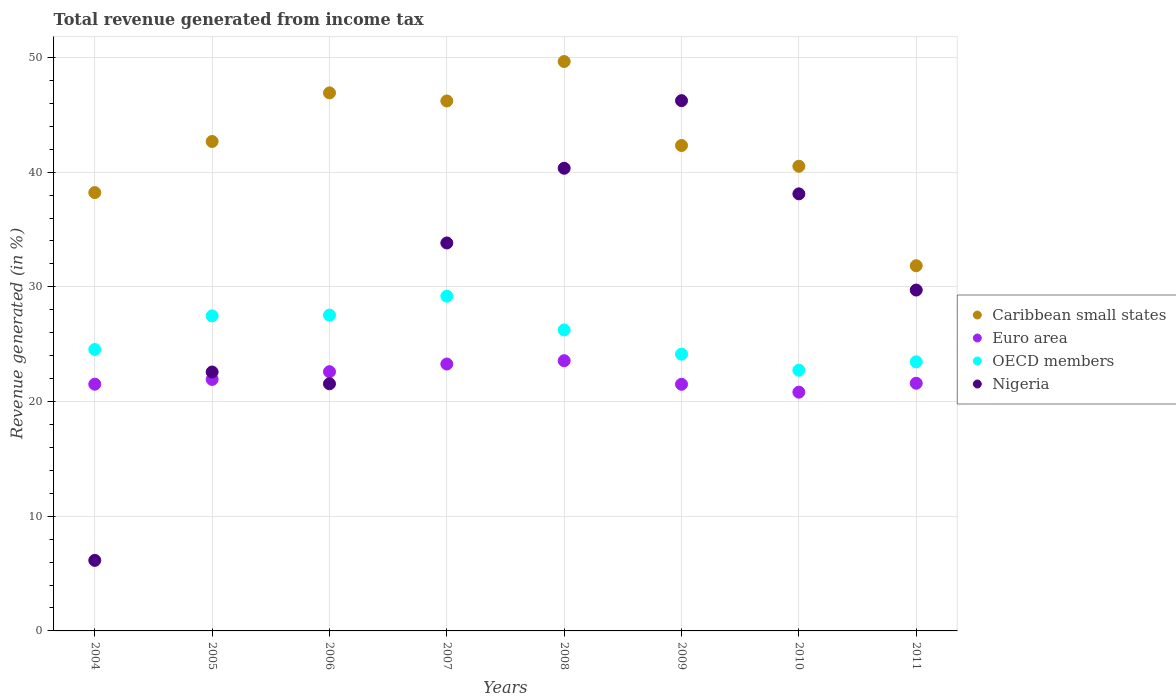How many different coloured dotlines are there?
Provide a short and direct response. 4. Is the number of dotlines equal to the number of legend labels?
Offer a very short reply. Yes. What is the total revenue generated in OECD members in 2004?
Make the answer very short. 24.54. Across all years, what is the maximum total revenue generated in OECD members?
Ensure brevity in your answer.  29.19. Across all years, what is the minimum total revenue generated in OECD members?
Give a very brief answer. 22.73. What is the total total revenue generated in Euro area in the graph?
Your answer should be very brief. 176.78. What is the difference between the total revenue generated in Euro area in 2004 and that in 2009?
Offer a very short reply. 0.01. What is the difference between the total revenue generated in OECD members in 2007 and the total revenue generated in Caribbean small states in 2008?
Keep it short and to the point. -20.46. What is the average total revenue generated in Euro area per year?
Your answer should be compact. 22.1. In the year 2009, what is the difference between the total revenue generated in Caribbean small states and total revenue generated in OECD members?
Your response must be concise. 18.19. What is the ratio of the total revenue generated in OECD members in 2004 to that in 2007?
Ensure brevity in your answer.  0.84. Is the total revenue generated in Nigeria in 2007 less than that in 2011?
Your answer should be very brief. No. What is the difference between the highest and the second highest total revenue generated in Nigeria?
Offer a terse response. 5.9. What is the difference between the highest and the lowest total revenue generated in OECD members?
Provide a short and direct response. 6.46. In how many years, is the total revenue generated in Nigeria greater than the average total revenue generated in Nigeria taken over all years?
Your response must be concise. 4. Is the sum of the total revenue generated in OECD members in 2008 and 2010 greater than the maximum total revenue generated in Euro area across all years?
Your answer should be compact. Yes. Is it the case that in every year, the sum of the total revenue generated in Nigeria and total revenue generated in OECD members  is greater than the sum of total revenue generated in Euro area and total revenue generated in Caribbean small states?
Your response must be concise. No. Is it the case that in every year, the sum of the total revenue generated in OECD members and total revenue generated in Caribbean small states  is greater than the total revenue generated in Nigeria?
Give a very brief answer. Yes. Does the total revenue generated in Caribbean small states monotonically increase over the years?
Offer a terse response. No. Is the total revenue generated in Caribbean small states strictly greater than the total revenue generated in OECD members over the years?
Give a very brief answer. Yes. How many dotlines are there?
Your response must be concise. 4. What is the difference between two consecutive major ticks on the Y-axis?
Your answer should be compact. 10. Are the values on the major ticks of Y-axis written in scientific E-notation?
Provide a short and direct response. No. Does the graph contain any zero values?
Offer a very short reply. No. What is the title of the graph?
Offer a very short reply. Total revenue generated from income tax. Does "Bangladesh" appear as one of the legend labels in the graph?
Your answer should be compact. No. What is the label or title of the X-axis?
Provide a short and direct response. Years. What is the label or title of the Y-axis?
Your response must be concise. Revenue generated (in %). What is the Revenue generated (in %) of Caribbean small states in 2004?
Offer a terse response. 38.22. What is the Revenue generated (in %) of Euro area in 2004?
Offer a very short reply. 21.51. What is the Revenue generated (in %) in OECD members in 2004?
Make the answer very short. 24.54. What is the Revenue generated (in %) of Nigeria in 2004?
Your answer should be very brief. 6.15. What is the Revenue generated (in %) in Caribbean small states in 2005?
Offer a very short reply. 42.67. What is the Revenue generated (in %) of Euro area in 2005?
Your response must be concise. 21.93. What is the Revenue generated (in %) in OECD members in 2005?
Provide a short and direct response. 27.47. What is the Revenue generated (in %) in Nigeria in 2005?
Offer a terse response. 22.57. What is the Revenue generated (in %) of Caribbean small states in 2006?
Offer a terse response. 46.91. What is the Revenue generated (in %) in Euro area in 2006?
Offer a very short reply. 22.6. What is the Revenue generated (in %) in OECD members in 2006?
Make the answer very short. 27.53. What is the Revenue generated (in %) in Nigeria in 2006?
Your answer should be compact. 21.55. What is the Revenue generated (in %) of Caribbean small states in 2007?
Keep it short and to the point. 46.21. What is the Revenue generated (in %) in Euro area in 2007?
Offer a very short reply. 23.27. What is the Revenue generated (in %) of OECD members in 2007?
Offer a very short reply. 29.19. What is the Revenue generated (in %) in Nigeria in 2007?
Make the answer very short. 33.83. What is the Revenue generated (in %) of Caribbean small states in 2008?
Provide a succinct answer. 49.65. What is the Revenue generated (in %) of Euro area in 2008?
Your response must be concise. 23.56. What is the Revenue generated (in %) in OECD members in 2008?
Keep it short and to the point. 26.24. What is the Revenue generated (in %) of Nigeria in 2008?
Keep it short and to the point. 40.34. What is the Revenue generated (in %) in Caribbean small states in 2009?
Offer a terse response. 42.32. What is the Revenue generated (in %) of Euro area in 2009?
Give a very brief answer. 21.5. What is the Revenue generated (in %) in OECD members in 2009?
Your answer should be very brief. 24.13. What is the Revenue generated (in %) in Nigeria in 2009?
Offer a very short reply. 46.23. What is the Revenue generated (in %) in Caribbean small states in 2010?
Offer a terse response. 40.51. What is the Revenue generated (in %) of Euro area in 2010?
Your answer should be compact. 20.82. What is the Revenue generated (in %) in OECD members in 2010?
Provide a short and direct response. 22.73. What is the Revenue generated (in %) in Nigeria in 2010?
Offer a terse response. 38.11. What is the Revenue generated (in %) of Caribbean small states in 2011?
Your answer should be compact. 31.84. What is the Revenue generated (in %) of Euro area in 2011?
Provide a succinct answer. 21.59. What is the Revenue generated (in %) in OECD members in 2011?
Keep it short and to the point. 23.46. What is the Revenue generated (in %) in Nigeria in 2011?
Your answer should be very brief. 29.72. Across all years, what is the maximum Revenue generated (in %) of Caribbean small states?
Your answer should be very brief. 49.65. Across all years, what is the maximum Revenue generated (in %) in Euro area?
Offer a very short reply. 23.56. Across all years, what is the maximum Revenue generated (in %) in OECD members?
Provide a short and direct response. 29.19. Across all years, what is the maximum Revenue generated (in %) in Nigeria?
Ensure brevity in your answer.  46.23. Across all years, what is the minimum Revenue generated (in %) of Caribbean small states?
Provide a short and direct response. 31.84. Across all years, what is the minimum Revenue generated (in %) of Euro area?
Keep it short and to the point. 20.82. Across all years, what is the minimum Revenue generated (in %) in OECD members?
Provide a short and direct response. 22.73. Across all years, what is the minimum Revenue generated (in %) of Nigeria?
Your response must be concise. 6.15. What is the total Revenue generated (in %) of Caribbean small states in the graph?
Offer a terse response. 338.33. What is the total Revenue generated (in %) of Euro area in the graph?
Provide a succinct answer. 176.78. What is the total Revenue generated (in %) in OECD members in the graph?
Provide a short and direct response. 205.29. What is the total Revenue generated (in %) of Nigeria in the graph?
Ensure brevity in your answer.  238.5. What is the difference between the Revenue generated (in %) in Caribbean small states in 2004 and that in 2005?
Give a very brief answer. -4.45. What is the difference between the Revenue generated (in %) of Euro area in 2004 and that in 2005?
Your response must be concise. -0.42. What is the difference between the Revenue generated (in %) in OECD members in 2004 and that in 2005?
Ensure brevity in your answer.  -2.93. What is the difference between the Revenue generated (in %) in Nigeria in 2004 and that in 2005?
Keep it short and to the point. -16.42. What is the difference between the Revenue generated (in %) in Caribbean small states in 2004 and that in 2006?
Ensure brevity in your answer.  -8.69. What is the difference between the Revenue generated (in %) of Euro area in 2004 and that in 2006?
Make the answer very short. -1.09. What is the difference between the Revenue generated (in %) of OECD members in 2004 and that in 2006?
Offer a very short reply. -3. What is the difference between the Revenue generated (in %) of Nigeria in 2004 and that in 2006?
Offer a very short reply. -15.4. What is the difference between the Revenue generated (in %) in Caribbean small states in 2004 and that in 2007?
Provide a succinct answer. -7.99. What is the difference between the Revenue generated (in %) in Euro area in 2004 and that in 2007?
Keep it short and to the point. -1.76. What is the difference between the Revenue generated (in %) of OECD members in 2004 and that in 2007?
Give a very brief answer. -4.65. What is the difference between the Revenue generated (in %) of Nigeria in 2004 and that in 2007?
Your answer should be very brief. -27.68. What is the difference between the Revenue generated (in %) of Caribbean small states in 2004 and that in 2008?
Give a very brief answer. -11.43. What is the difference between the Revenue generated (in %) of Euro area in 2004 and that in 2008?
Offer a very short reply. -2.05. What is the difference between the Revenue generated (in %) in OECD members in 2004 and that in 2008?
Provide a succinct answer. -1.7. What is the difference between the Revenue generated (in %) of Nigeria in 2004 and that in 2008?
Give a very brief answer. -34.19. What is the difference between the Revenue generated (in %) of Caribbean small states in 2004 and that in 2009?
Make the answer very short. -4.11. What is the difference between the Revenue generated (in %) in Euro area in 2004 and that in 2009?
Offer a terse response. 0.01. What is the difference between the Revenue generated (in %) in OECD members in 2004 and that in 2009?
Provide a succinct answer. 0.41. What is the difference between the Revenue generated (in %) in Nigeria in 2004 and that in 2009?
Offer a very short reply. -40.08. What is the difference between the Revenue generated (in %) of Caribbean small states in 2004 and that in 2010?
Provide a short and direct response. -2.3. What is the difference between the Revenue generated (in %) in Euro area in 2004 and that in 2010?
Offer a very short reply. 0.69. What is the difference between the Revenue generated (in %) of OECD members in 2004 and that in 2010?
Make the answer very short. 1.81. What is the difference between the Revenue generated (in %) in Nigeria in 2004 and that in 2010?
Your response must be concise. -31.96. What is the difference between the Revenue generated (in %) of Caribbean small states in 2004 and that in 2011?
Provide a short and direct response. 6.38. What is the difference between the Revenue generated (in %) of Euro area in 2004 and that in 2011?
Make the answer very short. -0.08. What is the difference between the Revenue generated (in %) in OECD members in 2004 and that in 2011?
Ensure brevity in your answer.  1.07. What is the difference between the Revenue generated (in %) in Nigeria in 2004 and that in 2011?
Keep it short and to the point. -23.57. What is the difference between the Revenue generated (in %) of Caribbean small states in 2005 and that in 2006?
Ensure brevity in your answer.  -4.24. What is the difference between the Revenue generated (in %) in Euro area in 2005 and that in 2006?
Your answer should be very brief. -0.67. What is the difference between the Revenue generated (in %) of OECD members in 2005 and that in 2006?
Offer a terse response. -0.07. What is the difference between the Revenue generated (in %) of Nigeria in 2005 and that in 2006?
Give a very brief answer. 1.03. What is the difference between the Revenue generated (in %) in Caribbean small states in 2005 and that in 2007?
Offer a terse response. -3.53. What is the difference between the Revenue generated (in %) in Euro area in 2005 and that in 2007?
Your response must be concise. -1.34. What is the difference between the Revenue generated (in %) of OECD members in 2005 and that in 2007?
Provide a short and direct response. -1.72. What is the difference between the Revenue generated (in %) of Nigeria in 2005 and that in 2007?
Your answer should be compact. -11.25. What is the difference between the Revenue generated (in %) of Caribbean small states in 2005 and that in 2008?
Your answer should be compact. -6.97. What is the difference between the Revenue generated (in %) in Euro area in 2005 and that in 2008?
Your response must be concise. -1.63. What is the difference between the Revenue generated (in %) in OECD members in 2005 and that in 2008?
Offer a very short reply. 1.23. What is the difference between the Revenue generated (in %) in Nigeria in 2005 and that in 2008?
Ensure brevity in your answer.  -17.77. What is the difference between the Revenue generated (in %) in Caribbean small states in 2005 and that in 2009?
Your answer should be compact. 0.35. What is the difference between the Revenue generated (in %) of Euro area in 2005 and that in 2009?
Ensure brevity in your answer.  0.42. What is the difference between the Revenue generated (in %) in OECD members in 2005 and that in 2009?
Your answer should be compact. 3.34. What is the difference between the Revenue generated (in %) of Nigeria in 2005 and that in 2009?
Keep it short and to the point. -23.66. What is the difference between the Revenue generated (in %) of Caribbean small states in 2005 and that in 2010?
Your answer should be compact. 2.16. What is the difference between the Revenue generated (in %) of Euro area in 2005 and that in 2010?
Your response must be concise. 1.11. What is the difference between the Revenue generated (in %) of OECD members in 2005 and that in 2010?
Your answer should be very brief. 4.74. What is the difference between the Revenue generated (in %) of Nigeria in 2005 and that in 2010?
Your response must be concise. -15.53. What is the difference between the Revenue generated (in %) in Caribbean small states in 2005 and that in 2011?
Keep it short and to the point. 10.83. What is the difference between the Revenue generated (in %) of Euro area in 2005 and that in 2011?
Make the answer very short. 0.33. What is the difference between the Revenue generated (in %) of OECD members in 2005 and that in 2011?
Ensure brevity in your answer.  4.01. What is the difference between the Revenue generated (in %) in Nigeria in 2005 and that in 2011?
Offer a terse response. -7.15. What is the difference between the Revenue generated (in %) in Caribbean small states in 2006 and that in 2007?
Provide a succinct answer. 0.7. What is the difference between the Revenue generated (in %) in Euro area in 2006 and that in 2007?
Offer a very short reply. -0.67. What is the difference between the Revenue generated (in %) of OECD members in 2006 and that in 2007?
Keep it short and to the point. -1.65. What is the difference between the Revenue generated (in %) in Nigeria in 2006 and that in 2007?
Ensure brevity in your answer.  -12.28. What is the difference between the Revenue generated (in %) in Caribbean small states in 2006 and that in 2008?
Keep it short and to the point. -2.74. What is the difference between the Revenue generated (in %) in Euro area in 2006 and that in 2008?
Make the answer very short. -0.96. What is the difference between the Revenue generated (in %) in OECD members in 2006 and that in 2008?
Provide a succinct answer. 1.29. What is the difference between the Revenue generated (in %) in Nigeria in 2006 and that in 2008?
Ensure brevity in your answer.  -18.79. What is the difference between the Revenue generated (in %) in Caribbean small states in 2006 and that in 2009?
Make the answer very short. 4.59. What is the difference between the Revenue generated (in %) in Euro area in 2006 and that in 2009?
Your answer should be very brief. 1.1. What is the difference between the Revenue generated (in %) of OECD members in 2006 and that in 2009?
Give a very brief answer. 3.4. What is the difference between the Revenue generated (in %) in Nigeria in 2006 and that in 2009?
Your answer should be very brief. -24.69. What is the difference between the Revenue generated (in %) in Caribbean small states in 2006 and that in 2010?
Your answer should be very brief. 6.4. What is the difference between the Revenue generated (in %) of Euro area in 2006 and that in 2010?
Your answer should be very brief. 1.78. What is the difference between the Revenue generated (in %) of OECD members in 2006 and that in 2010?
Provide a succinct answer. 4.8. What is the difference between the Revenue generated (in %) in Nigeria in 2006 and that in 2010?
Offer a very short reply. -16.56. What is the difference between the Revenue generated (in %) in Caribbean small states in 2006 and that in 2011?
Your response must be concise. 15.07. What is the difference between the Revenue generated (in %) of OECD members in 2006 and that in 2011?
Your response must be concise. 4.07. What is the difference between the Revenue generated (in %) in Nigeria in 2006 and that in 2011?
Keep it short and to the point. -8.17. What is the difference between the Revenue generated (in %) of Caribbean small states in 2007 and that in 2008?
Offer a terse response. -3.44. What is the difference between the Revenue generated (in %) of Euro area in 2007 and that in 2008?
Provide a succinct answer. -0.29. What is the difference between the Revenue generated (in %) in OECD members in 2007 and that in 2008?
Your response must be concise. 2.94. What is the difference between the Revenue generated (in %) of Nigeria in 2007 and that in 2008?
Your response must be concise. -6.51. What is the difference between the Revenue generated (in %) in Caribbean small states in 2007 and that in 2009?
Provide a succinct answer. 3.88. What is the difference between the Revenue generated (in %) in Euro area in 2007 and that in 2009?
Keep it short and to the point. 1.77. What is the difference between the Revenue generated (in %) in OECD members in 2007 and that in 2009?
Your answer should be very brief. 5.06. What is the difference between the Revenue generated (in %) of Nigeria in 2007 and that in 2009?
Ensure brevity in your answer.  -12.41. What is the difference between the Revenue generated (in %) in Caribbean small states in 2007 and that in 2010?
Make the answer very short. 5.69. What is the difference between the Revenue generated (in %) of Euro area in 2007 and that in 2010?
Provide a short and direct response. 2.45. What is the difference between the Revenue generated (in %) of OECD members in 2007 and that in 2010?
Give a very brief answer. 6.46. What is the difference between the Revenue generated (in %) in Nigeria in 2007 and that in 2010?
Keep it short and to the point. -4.28. What is the difference between the Revenue generated (in %) in Caribbean small states in 2007 and that in 2011?
Provide a succinct answer. 14.37. What is the difference between the Revenue generated (in %) in Euro area in 2007 and that in 2011?
Provide a succinct answer. 1.68. What is the difference between the Revenue generated (in %) of OECD members in 2007 and that in 2011?
Ensure brevity in your answer.  5.72. What is the difference between the Revenue generated (in %) in Nigeria in 2007 and that in 2011?
Ensure brevity in your answer.  4.11. What is the difference between the Revenue generated (in %) of Caribbean small states in 2008 and that in 2009?
Your answer should be very brief. 7.32. What is the difference between the Revenue generated (in %) of Euro area in 2008 and that in 2009?
Make the answer very short. 2.06. What is the difference between the Revenue generated (in %) in OECD members in 2008 and that in 2009?
Your response must be concise. 2.11. What is the difference between the Revenue generated (in %) in Nigeria in 2008 and that in 2009?
Give a very brief answer. -5.9. What is the difference between the Revenue generated (in %) of Caribbean small states in 2008 and that in 2010?
Keep it short and to the point. 9.13. What is the difference between the Revenue generated (in %) of Euro area in 2008 and that in 2010?
Provide a succinct answer. 2.74. What is the difference between the Revenue generated (in %) in OECD members in 2008 and that in 2010?
Offer a very short reply. 3.51. What is the difference between the Revenue generated (in %) in Nigeria in 2008 and that in 2010?
Give a very brief answer. 2.23. What is the difference between the Revenue generated (in %) in Caribbean small states in 2008 and that in 2011?
Provide a short and direct response. 17.81. What is the difference between the Revenue generated (in %) in Euro area in 2008 and that in 2011?
Offer a very short reply. 1.97. What is the difference between the Revenue generated (in %) of OECD members in 2008 and that in 2011?
Give a very brief answer. 2.78. What is the difference between the Revenue generated (in %) of Nigeria in 2008 and that in 2011?
Ensure brevity in your answer.  10.62. What is the difference between the Revenue generated (in %) in Caribbean small states in 2009 and that in 2010?
Your response must be concise. 1.81. What is the difference between the Revenue generated (in %) in Euro area in 2009 and that in 2010?
Your response must be concise. 0.69. What is the difference between the Revenue generated (in %) in OECD members in 2009 and that in 2010?
Ensure brevity in your answer.  1.4. What is the difference between the Revenue generated (in %) in Nigeria in 2009 and that in 2010?
Ensure brevity in your answer.  8.13. What is the difference between the Revenue generated (in %) in Caribbean small states in 2009 and that in 2011?
Your response must be concise. 10.48. What is the difference between the Revenue generated (in %) in Euro area in 2009 and that in 2011?
Ensure brevity in your answer.  -0.09. What is the difference between the Revenue generated (in %) in OECD members in 2009 and that in 2011?
Your answer should be very brief. 0.67. What is the difference between the Revenue generated (in %) of Nigeria in 2009 and that in 2011?
Your response must be concise. 16.51. What is the difference between the Revenue generated (in %) of Caribbean small states in 2010 and that in 2011?
Offer a very short reply. 8.67. What is the difference between the Revenue generated (in %) of Euro area in 2010 and that in 2011?
Provide a short and direct response. -0.78. What is the difference between the Revenue generated (in %) in OECD members in 2010 and that in 2011?
Give a very brief answer. -0.73. What is the difference between the Revenue generated (in %) of Nigeria in 2010 and that in 2011?
Keep it short and to the point. 8.39. What is the difference between the Revenue generated (in %) of Caribbean small states in 2004 and the Revenue generated (in %) of Euro area in 2005?
Give a very brief answer. 16.29. What is the difference between the Revenue generated (in %) in Caribbean small states in 2004 and the Revenue generated (in %) in OECD members in 2005?
Give a very brief answer. 10.75. What is the difference between the Revenue generated (in %) of Caribbean small states in 2004 and the Revenue generated (in %) of Nigeria in 2005?
Make the answer very short. 15.64. What is the difference between the Revenue generated (in %) in Euro area in 2004 and the Revenue generated (in %) in OECD members in 2005?
Make the answer very short. -5.96. What is the difference between the Revenue generated (in %) in Euro area in 2004 and the Revenue generated (in %) in Nigeria in 2005?
Keep it short and to the point. -1.06. What is the difference between the Revenue generated (in %) of OECD members in 2004 and the Revenue generated (in %) of Nigeria in 2005?
Give a very brief answer. 1.96. What is the difference between the Revenue generated (in %) in Caribbean small states in 2004 and the Revenue generated (in %) in Euro area in 2006?
Your response must be concise. 15.62. What is the difference between the Revenue generated (in %) of Caribbean small states in 2004 and the Revenue generated (in %) of OECD members in 2006?
Your answer should be compact. 10.68. What is the difference between the Revenue generated (in %) of Caribbean small states in 2004 and the Revenue generated (in %) of Nigeria in 2006?
Make the answer very short. 16.67. What is the difference between the Revenue generated (in %) in Euro area in 2004 and the Revenue generated (in %) in OECD members in 2006?
Provide a succinct answer. -6.02. What is the difference between the Revenue generated (in %) in Euro area in 2004 and the Revenue generated (in %) in Nigeria in 2006?
Keep it short and to the point. -0.04. What is the difference between the Revenue generated (in %) in OECD members in 2004 and the Revenue generated (in %) in Nigeria in 2006?
Make the answer very short. 2.99. What is the difference between the Revenue generated (in %) in Caribbean small states in 2004 and the Revenue generated (in %) in Euro area in 2007?
Make the answer very short. 14.95. What is the difference between the Revenue generated (in %) in Caribbean small states in 2004 and the Revenue generated (in %) in OECD members in 2007?
Offer a very short reply. 9.03. What is the difference between the Revenue generated (in %) in Caribbean small states in 2004 and the Revenue generated (in %) in Nigeria in 2007?
Give a very brief answer. 4.39. What is the difference between the Revenue generated (in %) of Euro area in 2004 and the Revenue generated (in %) of OECD members in 2007?
Keep it short and to the point. -7.67. What is the difference between the Revenue generated (in %) in Euro area in 2004 and the Revenue generated (in %) in Nigeria in 2007?
Give a very brief answer. -12.31. What is the difference between the Revenue generated (in %) in OECD members in 2004 and the Revenue generated (in %) in Nigeria in 2007?
Offer a very short reply. -9.29. What is the difference between the Revenue generated (in %) of Caribbean small states in 2004 and the Revenue generated (in %) of Euro area in 2008?
Provide a succinct answer. 14.66. What is the difference between the Revenue generated (in %) of Caribbean small states in 2004 and the Revenue generated (in %) of OECD members in 2008?
Make the answer very short. 11.98. What is the difference between the Revenue generated (in %) in Caribbean small states in 2004 and the Revenue generated (in %) in Nigeria in 2008?
Give a very brief answer. -2.12. What is the difference between the Revenue generated (in %) in Euro area in 2004 and the Revenue generated (in %) in OECD members in 2008?
Your answer should be compact. -4.73. What is the difference between the Revenue generated (in %) in Euro area in 2004 and the Revenue generated (in %) in Nigeria in 2008?
Provide a succinct answer. -18.83. What is the difference between the Revenue generated (in %) of OECD members in 2004 and the Revenue generated (in %) of Nigeria in 2008?
Make the answer very short. -15.8. What is the difference between the Revenue generated (in %) in Caribbean small states in 2004 and the Revenue generated (in %) in Euro area in 2009?
Your answer should be very brief. 16.71. What is the difference between the Revenue generated (in %) of Caribbean small states in 2004 and the Revenue generated (in %) of OECD members in 2009?
Your answer should be very brief. 14.09. What is the difference between the Revenue generated (in %) in Caribbean small states in 2004 and the Revenue generated (in %) in Nigeria in 2009?
Give a very brief answer. -8.02. What is the difference between the Revenue generated (in %) in Euro area in 2004 and the Revenue generated (in %) in OECD members in 2009?
Make the answer very short. -2.62. What is the difference between the Revenue generated (in %) in Euro area in 2004 and the Revenue generated (in %) in Nigeria in 2009?
Make the answer very short. -24.72. What is the difference between the Revenue generated (in %) of OECD members in 2004 and the Revenue generated (in %) of Nigeria in 2009?
Offer a terse response. -21.7. What is the difference between the Revenue generated (in %) of Caribbean small states in 2004 and the Revenue generated (in %) of Euro area in 2010?
Offer a terse response. 17.4. What is the difference between the Revenue generated (in %) of Caribbean small states in 2004 and the Revenue generated (in %) of OECD members in 2010?
Keep it short and to the point. 15.49. What is the difference between the Revenue generated (in %) of Caribbean small states in 2004 and the Revenue generated (in %) of Nigeria in 2010?
Your answer should be very brief. 0.11. What is the difference between the Revenue generated (in %) in Euro area in 2004 and the Revenue generated (in %) in OECD members in 2010?
Give a very brief answer. -1.22. What is the difference between the Revenue generated (in %) in Euro area in 2004 and the Revenue generated (in %) in Nigeria in 2010?
Provide a succinct answer. -16.6. What is the difference between the Revenue generated (in %) in OECD members in 2004 and the Revenue generated (in %) in Nigeria in 2010?
Your response must be concise. -13.57. What is the difference between the Revenue generated (in %) of Caribbean small states in 2004 and the Revenue generated (in %) of Euro area in 2011?
Offer a very short reply. 16.62. What is the difference between the Revenue generated (in %) in Caribbean small states in 2004 and the Revenue generated (in %) in OECD members in 2011?
Your response must be concise. 14.75. What is the difference between the Revenue generated (in %) in Caribbean small states in 2004 and the Revenue generated (in %) in Nigeria in 2011?
Give a very brief answer. 8.5. What is the difference between the Revenue generated (in %) in Euro area in 2004 and the Revenue generated (in %) in OECD members in 2011?
Give a very brief answer. -1.95. What is the difference between the Revenue generated (in %) of Euro area in 2004 and the Revenue generated (in %) of Nigeria in 2011?
Your answer should be compact. -8.21. What is the difference between the Revenue generated (in %) of OECD members in 2004 and the Revenue generated (in %) of Nigeria in 2011?
Your answer should be very brief. -5.18. What is the difference between the Revenue generated (in %) in Caribbean small states in 2005 and the Revenue generated (in %) in Euro area in 2006?
Your answer should be very brief. 20.07. What is the difference between the Revenue generated (in %) in Caribbean small states in 2005 and the Revenue generated (in %) in OECD members in 2006?
Provide a succinct answer. 15.14. What is the difference between the Revenue generated (in %) of Caribbean small states in 2005 and the Revenue generated (in %) of Nigeria in 2006?
Provide a short and direct response. 21.12. What is the difference between the Revenue generated (in %) of Euro area in 2005 and the Revenue generated (in %) of OECD members in 2006?
Your answer should be compact. -5.61. What is the difference between the Revenue generated (in %) of Euro area in 2005 and the Revenue generated (in %) of Nigeria in 2006?
Provide a succinct answer. 0.38. What is the difference between the Revenue generated (in %) in OECD members in 2005 and the Revenue generated (in %) in Nigeria in 2006?
Your response must be concise. 5.92. What is the difference between the Revenue generated (in %) in Caribbean small states in 2005 and the Revenue generated (in %) in Euro area in 2007?
Keep it short and to the point. 19.4. What is the difference between the Revenue generated (in %) in Caribbean small states in 2005 and the Revenue generated (in %) in OECD members in 2007?
Your answer should be very brief. 13.49. What is the difference between the Revenue generated (in %) of Caribbean small states in 2005 and the Revenue generated (in %) of Nigeria in 2007?
Offer a terse response. 8.85. What is the difference between the Revenue generated (in %) in Euro area in 2005 and the Revenue generated (in %) in OECD members in 2007?
Keep it short and to the point. -7.26. What is the difference between the Revenue generated (in %) in Euro area in 2005 and the Revenue generated (in %) in Nigeria in 2007?
Give a very brief answer. -11.9. What is the difference between the Revenue generated (in %) in OECD members in 2005 and the Revenue generated (in %) in Nigeria in 2007?
Give a very brief answer. -6.36. What is the difference between the Revenue generated (in %) in Caribbean small states in 2005 and the Revenue generated (in %) in Euro area in 2008?
Provide a succinct answer. 19.11. What is the difference between the Revenue generated (in %) in Caribbean small states in 2005 and the Revenue generated (in %) in OECD members in 2008?
Your answer should be very brief. 16.43. What is the difference between the Revenue generated (in %) in Caribbean small states in 2005 and the Revenue generated (in %) in Nigeria in 2008?
Your answer should be very brief. 2.33. What is the difference between the Revenue generated (in %) in Euro area in 2005 and the Revenue generated (in %) in OECD members in 2008?
Make the answer very short. -4.31. What is the difference between the Revenue generated (in %) of Euro area in 2005 and the Revenue generated (in %) of Nigeria in 2008?
Give a very brief answer. -18.41. What is the difference between the Revenue generated (in %) of OECD members in 2005 and the Revenue generated (in %) of Nigeria in 2008?
Offer a very short reply. -12.87. What is the difference between the Revenue generated (in %) in Caribbean small states in 2005 and the Revenue generated (in %) in Euro area in 2009?
Keep it short and to the point. 21.17. What is the difference between the Revenue generated (in %) of Caribbean small states in 2005 and the Revenue generated (in %) of OECD members in 2009?
Your answer should be compact. 18.54. What is the difference between the Revenue generated (in %) of Caribbean small states in 2005 and the Revenue generated (in %) of Nigeria in 2009?
Your answer should be very brief. -3.56. What is the difference between the Revenue generated (in %) in Euro area in 2005 and the Revenue generated (in %) in OECD members in 2009?
Your answer should be very brief. -2.2. What is the difference between the Revenue generated (in %) in Euro area in 2005 and the Revenue generated (in %) in Nigeria in 2009?
Ensure brevity in your answer.  -24.3. What is the difference between the Revenue generated (in %) in OECD members in 2005 and the Revenue generated (in %) in Nigeria in 2009?
Keep it short and to the point. -18.76. What is the difference between the Revenue generated (in %) of Caribbean small states in 2005 and the Revenue generated (in %) of Euro area in 2010?
Keep it short and to the point. 21.85. What is the difference between the Revenue generated (in %) in Caribbean small states in 2005 and the Revenue generated (in %) in OECD members in 2010?
Provide a succinct answer. 19.94. What is the difference between the Revenue generated (in %) of Caribbean small states in 2005 and the Revenue generated (in %) of Nigeria in 2010?
Your response must be concise. 4.56. What is the difference between the Revenue generated (in %) in Euro area in 2005 and the Revenue generated (in %) in OECD members in 2010?
Ensure brevity in your answer.  -0.8. What is the difference between the Revenue generated (in %) in Euro area in 2005 and the Revenue generated (in %) in Nigeria in 2010?
Offer a very short reply. -16.18. What is the difference between the Revenue generated (in %) of OECD members in 2005 and the Revenue generated (in %) of Nigeria in 2010?
Provide a short and direct response. -10.64. What is the difference between the Revenue generated (in %) of Caribbean small states in 2005 and the Revenue generated (in %) of Euro area in 2011?
Ensure brevity in your answer.  21.08. What is the difference between the Revenue generated (in %) in Caribbean small states in 2005 and the Revenue generated (in %) in OECD members in 2011?
Your answer should be compact. 19.21. What is the difference between the Revenue generated (in %) of Caribbean small states in 2005 and the Revenue generated (in %) of Nigeria in 2011?
Your response must be concise. 12.95. What is the difference between the Revenue generated (in %) in Euro area in 2005 and the Revenue generated (in %) in OECD members in 2011?
Keep it short and to the point. -1.53. What is the difference between the Revenue generated (in %) of Euro area in 2005 and the Revenue generated (in %) of Nigeria in 2011?
Ensure brevity in your answer.  -7.79. What is the difference between the Revenue generated (in %) in OECD members in 2005 and the Revenue generated (in %) in Nigeria in 2011?
Your answer should be very brief. -2.25. What is the difference between the Revenue generated (in %) in Caribbean small states in 2006 and the Revenue generated (in %) in Euro area in 2007?
Your answer should be compact. 23.64. What is the difference between the Revenue generated (in %) of Caribbean small states in 2006 and the Revenue generated (in %) of OECD members in 2007?
Your response must be concise. 17.72. What is the difference between the Revenue generated (in %) of Caribbean small states in 2006 and the Revenue generated (in %) of Nigeria in 2007?
Offer a very short reply. 13.08. What is the difference between the Revenue generated (in %) of Euro area in 2006 and the Revenue generated (in %) of OECD members in 2007?
Keep it short and to the point. -6.59. What is the difference between the Revenue generated (in %) of Euro area in 2006 and the Revenue generated (in %) of Nigeria in 2007?
Keep it short and to the point. -11.23. What is the difference between the Revenue generated (in %) in OECD members in 2006 and the Revenue generated (in %) in Nigeria in 2007?
Offer a very short reply. -6.29. What is the difference between the Revenue generated (in %) in Caribbean small states in 2006 and the Revenue generated (in %) in Euro area in 2008?
Provide a succinct answer. 23.35. What is the difference between the Revenue generated (in %) in Caribbean small states in 2006 and the Revenue generated (in %) in OECD members in 2008?
Your response must be concise. 20.67. What is the difference between the Revenue generated (in %) of Caribbean small states in 2006 and the Revenue generated (in %) of Nigeria in 2008?
Your response must be concise. 6.57. What is the difference between the Revenue generated (in %) of Euro area in 2006 and the Revenue generated (in %) of OECD members in 2008?
Your response must be concise. -3.64. What is the difference between the Revenue generated (in %) in Euro area in 2006 and the Revenue generated (in %) in Nigeria in 2008?
Your response must be concise. -17.74. What is the difference between the Revenue generated (in %) of OECD members in 2006 and the Revenue generated (in %) of Nigeria in 2008?
Your answer should be very brief. -12.8. What is the difference between the Revenue generated (in %) of Caribbean small states in 2006 and the Revenue generated (in %) of Euro area in 2009?
Offer a terse response. 25.41. What is the difference between the Revenue generated (in %) in Caribbean small states in 2006 and the Revenue generated (in %) in OECD members in 2009?
Your answer should be very brief. 22.78. What is the difference between the Revenue generated (in %) of Caribbean small states in 2006 and the Revenue generated (in %) of Nigeria in 2009?
Give a very brief answer. 0.68. What is the difference between the Revenue generated (in %) in Euro area in 2006 and the Revenue generated (in %) in OECD members in 2009?
Your response must be concise. -1.53. What is the difference between the Revenue generated (in %) of Euro area in 2006 and the Revenue generated (in %) of Nigeria in 2009?
Offer a terse response. -23.63. What is the difference between the Revenue generated (in %) of OECD members in 2006 and the Revenue generated (in %) of Nigeria in 2009?
Provide a succinct answer. -18.7. What is the difference between the Revenue generated (in %) of Caribbean small states in 2006 and the Revenue generated (in %) of Euro area in 2010?
Keep it short and to the point. 26.09. What is the difference between the Revenue generated (in %) of Caribbean small states in 2006 and the Revenue generated (in %) of OECD members in 2010?
Offer a very short reply. 24.18. What is the difference between the Revenue generated (in %) in Caribbean small states in 2006 and the Revenue generated (in %) in Nigeria in 2010?
Your response must be concise. 8.8. What is the difference between the Revenue generated (in %) of Euro area in 2006 and the Revenue generated (in %) of OECD members in 2010?
Ensure brevity in your answer.  -0.13. What is the difference between the Revenue generated (in %) in Euro area in 2006 and the Revenue generated (in %) in Nigeria in 2010?
Offer a terse response. -15.51. What is the difference between the Revenue generated (in %) of OECD members in 2006 and the Revenue generated (in %) of Nigeria in 2010?
Provide a succinct answer. -10.57. What is the difference between the Revenue generated (in %) of Caribbean small states in 2006 and the Revenue generated (in %) of Euro area in 2011?
Your response must be concise. 25.32. What is the difference between the Revenue generated (in %) in Caribbean small states in 2006 and the Revenue generated (in %) in OECD members in 2011?
Offer a terse response. 23.45. What is the difference between the Revenue generated (in %) in Caribbean small states in 2006 and the Revenue generated (in %) in Nigeria in 2011?
Provide a succinct answer. 17.19. What is the difference between the Revenue generated (in %) in Euro area in 2006 and the Revenue generated (in %) in OECD members in 2011?
Offer a very short reply. -0.86. What is the difference between the Revenue generated (in %) in Euro area in 2006 and the Revenue generated (in %) in Nigeria in 2011?
Give a very brief answer. -7.12. What is the difference between the Revenue generated (in %) in OECD members in 2006 and the Revenue generated (in %) in Nigeria in 2011?
Offer a terse response. -2.19. What is the difference between the Revenue generated (in %) in Caribbean small states in 2007 and the Revenue generated (in %) in Euro area in 2008?
Ensure brevity in your answer.  22.65. What is the difference between the Revenue generated (in %) in Caribbean small states in 2007 and the Revenue generated (in %) in OECD members in 2008?
Make the answer very short. 19.96. What is the difference between the Revenue generated (in %) of Caribbean small states in 2007 and the Revenue generated (in %) of Nigeria in 2008?
Your answer should be very brief. 5.87. What is the difference between the Revenue generated (in %) of Euro area in 2007 and the Revenue generated (in %) of OECD members in 2008?
Your answer should be very brief. -2.97. What is the difference between the Revenue generated (in %) in Euro area in 2007 and the Revenue generated (in %) in Nigeria in 2008?
Give a very brief answer. -17.07. What is the difference between the Revenue generated (in %) in OECD members in 2007 and the Revenue generated (in %) in Nigeria in 2008?
Provide a succinct answer. -11.15. What is the difference between the Revenue generated (in %) of Caribbean small states in 2007 and the Revenue generated (in %) of Euro area in 2009?
Ensure brevity in your answer.  24.7. What is the difference between the Revenue generated (in %) of Caribbean small states in 2007 and the Revenue generated (in %) of OECD members in 2009?
Your answer should be compact. 22.08. What is the difference between the Revenue generated (in %) of Caribbean small states in 2007 and the Revenue generated (in %) of Nigeria in 2009?
Your response must be concise. -0.03. What is the difference between the Revenue generated (in %) in Euro area in 2007 and the Revenue generated (in %) in OECD members in 2009?
Give a very brief answer. -0.86. What is the difference between the Revenue generated (in %) of Euro area in 2007 and the Revenue generated (in %) of Nigeria in 2009?
Keep it short and to the point. -22.96. What is the difference between the Revenue generated (in %) in OECD members in 2007 and the Revenue generated (in %) in Nigeria in 2009?
Your answer should be compact. -17.05. What is the difference between the Revenue generated (in %) in Caribbean small states in 2007 and the Revenue generated (in %) in Euro area in 2010?
Provide a succinct answer. 25.39. What is the difference between the Revenue generated (in %) in Caribbean small states in 2007 and the Revenue generated (in %) in OECD members in 2010?
Provide a short and direct response. 23.48. What is the difference between the Revenue generated (in %) in Caribbean small states in 2007 and the Revenue generated (in %) in Nigeria in 2010?
Provide a succinct answer. 8.1. What is the difference between the Revenue generated (in %) in Euro area in 2007 and the Revenue generated (in %) in OECD members in 2010?
Provide a short and direct response. 0.54. What is the difference between the Revenue generated (in %) of Euro area in 2007 and the Revenue generated (in %) of Nigeria in 2010?
Your response must be concise. -14.84. What is the difference between the Revenue generated (in %) in OECD members in 2007 and the Revenue generated (in %) in Nigeria in 2010?
Make the answer very short. -8.92. What is the difference between the Revenue generated (in %) in Caribbean small states in 2007 and the Revenue generated (in %) in Euro area in 2011?
Ensure brevity in your answer.  24.61. What is the difference between the Revenue generated (in %) in Caribbean small states in 2007 and the Revenue generated (in %) in OECD members in 2011?
Your answer should be compact. 22.74. What is the difference between the Revenue generated (in %) of Caribbean small states in 2007 and the Revenue generated (in %) of Nigeria in 2011?
Your response must be concise. 16.49. What is the difference between the Revenue generated (in %) in Euro area in 2007 and the Revenue generated (in %) in OECD members in 2011?
Offer a very short reply. -0.19. What is the difference between the Revenue generated (in %) of Euro area in 2007 and the Revenue generated (in %) of Nigeria in 2011?
Your response must be concise. -6.45. What is the difference between the Revenue generated (in %) of OECD members in 2007 and the Revenue generated (in %) of Nigeria in 2011?
Make the answer very short. -0.53. What is the difference between the Revenue generated (in %) of Caribbean small states in 2008 and the Revenue generated (in %) of Euro area in 2009?
Your answer should be very brief. 28.14. What is the difference between the Revenue generated (in %) in Caribbean small states in 2008 and the Revenue generated (in %) in OECD members in 2009?
Provide a short and direct response. 25.51. What is the difference between the Revenue generated (in %) of Caribbean small states in 2008 and the Revenue generated (in %) of Nigeria in 2009?
Ensure brevity in your answer.  3.41. What is the difference between the Revenue generated (in %) in Euro area in 2008 and the Revenue generated (in %) in OECD members in 2009?
Your response must be concise. -0.57. What is the difference between the Revenue generated (in %) of Euro area in 2008 and the Revenue generated (in %) of Nigeria in 2009?
Provide a short and direct response. -22.67. What is the difference between the Revenue generated (in %) in OECD members in 2008 and the Revenue generated (in %) in Nigeria in 2009?
Your answer should be compact. -19.99. What is the difference between the Revenue generated (in %) of Caribbean small states in 2008 and the Revenue generated (in %) of Euro area in 2010?
Make the answer very short. 28.83. What is the difference between the Revenue generated (in %) of Caribbean small states in 2008 and the Revenue generated (in %) of OECD members in 2010?
Provide a short and direct response. 26.91. What is the difference between the Revenue generated (in %) of Caribbean small states in 2008 and the Revenue generated (in %) of Nigeria in 2010?
Your answer should be compact. 11.54. What is the difference between the Revenue generated (in %) in Euro area in 2008 and the Revenue generated (in %) in OECD members in 2010?
Your response must be concise. 0.83. What is the difference between the Revenue generated (in %) in Euro area in 2008 and the Revenue generated (in %) in Nigeria in 2010?
Your answer should be compact. -14.55. What is the difference between the Revenue generated (in %) in OECD members in 2008 and the Revenue generated (in %) in Nigeria in 2010?
Your answer should be very brief. -11.87. What is the difference between the Revenue generated (in %) of Caribbean small states in 2008 and the Revenue generated (in %) of Euro area in 2011?
Ensure brevity in your answer.  28.05. What is the difference between the Revenue generated (in %) in Caribbean small states in 2008 and the Revenue generated (in %) in OECD members in 2011?
Ensure brevity in your answer.  26.18. What is the difference between the Revenue generated (in %) of Caribbean small states in 2008 and the Revenue generated (in %) of Nigeria in 2011?
Offer a very short reply. 19.93. What is the difference between the Revenue generated (in %) of Euro area in 2008 and the Revenue generated (in %) of OECD members in 2011?
Provide a succinct answer. 0.1. What is the difference between the Revenue generated (in %) in Euro area in 2008 and the Revenue generated (in %) in Nigeria in 2011?
Provide a succinct answer. -6.16. What is the difference between the Revenue generated (in %) in OECD members in 2008 and the Revenue generated (in %) in Nigeria in 2011?
Your response must be concise. -3.48. What is the difference between the Revenue generated (in %) in Caribbean small states in 2009 and the Revenue generated (in %) in Euro area in 2010?
Give a very brief answer. 21.51. What is the difference between the Revenue generated (in %) of Caribbean small states in 2009 and the Revenue generated (in %) of OECD members in 2010?
Your answer should be compact. 19.59. What is the difference between the Revenue generated (in %) of Caribbean small states in 2009 and the Revenue generated (in %) of Nigeria in 2010?
Provide a short and direct response. 4.22. What is the difference between the Revenue generated (in %) in Euro area in 2009 and the Revenue generated (in %) in OECD members in 2010?
Offer a very short reply. -1.23. What is the difference between the Revenue generated (in %) of Euro area in 2009 and the Revenue generated (in %) of Nigeria in 2010?
Ensure brevity in your answer.  -16.6. What is the difference between the Revenue generated (in %) of OECD members in 2009 and the Revenue generated (in %) of Nigeria in 2010?
Make the answer very short. -13.98. What is the difference between the Revenue generated (in %) in Caribbean small states in 2009 and the Revenue generated (in %) in Euro area in 2011?
Make the answer very short. 20.73. What is the difference between the Revenue generated (in %) of Caribbean small states in 2009 and the Revenue generated (in %) of OECD members in 2011?
Your response must be concise. 18.86. What is the difference between the Revenue generated (in %) of Caribbean small states in 2009 and the Revenue generated (in %) of Nigeria in 2011?
Your answer should be very brief. 12.6. What is the difference between the Revenue generated (in %) of Euro area in 2009 and the Revenue generated (in %) of OECD members in 2011?
Your answer should be very brief. -1.96. What is the difference between the Revenue generated (in %) of Euro area in 2009 and the Revenue generated (in %) of Nigeria in 2011?
Give a very brief answer. -8.22. What is the difference between the Revenue generated (in %) of OECD members in 2009 and the Revenue generated (in %) of Nigeria in 2011?
Your answer should be very brief. -5.59. What is the difference between the Revenue generated (in %) of Caribbean small states in 2010 and the Revenue generated (in %) of Euro area in 2011?
Offer a very short reply. 18.92. What is the difference between the Revenue generated (in %) in Caribbean small states in 2010 and the Revenue generated (in %) in OECD members in 2011?
Offer a very short reply. 17.05. What is the difference between the Revenue generated (in %) in Caribbean small states in 2010 and the Revenue generated (in %) in Nigeria in 2011?
Make the answer very short. 10.79. What is the difference between the Revenue generated (in %) of Euro area in 2010 and the Revenue generated (in %) of OECD members in 2011?
Offer a very short reply. -2.65. What is the difference between the Revenue generated (in %) in Euro area in 2010 and the Revenue generated (in %) in Nigeria in 2011?
Give a very brief answer. -8.9. What is the difference between the Revenue generated (in %) in OECD members in 2010 and the Revenue generated (in %) in Nigeria in 2011?
Your answer should be very brief. -6.99. What is the average Revenue generated (in %) in Caribbean small states per year?
Keep it short and to the point. 42.29. What is the average Revenue generated (in %) of Euro area per year?
Your answer should be compact. 22.1. What is the average Revenue generated (in %) of OECD members per year?
Provide a short and direct response. 25.66. What is the average Revenue generated (in %) of Nigeria per year?
Give a very brief answer. 29.81. In the year 2004, what is the difference between the Revenue generated (in %) in Caribbean small states and Revenue generated (in %) in Euro area?
Provide a short and direct response. 16.71. In the year 2004, what is the difference between the Revenue generated (in %) of Caribbean small states and Revenue generated (in %) of OECD members?
Give a very brief answer. 13.68. In the year 2004, what is the difference between the Revenue generated (in %) of Caribbean small states and Revenue generated (in %) of Nigeria?
Offer a very short reply. 32.07. In the year 2004, what is the difference between the Revenue generated (in %) in Euro area and Revenue generated (in %) in OECD members?
Make the answer very short. -3.03. In the year 2004, what is the difference between the Revenue generated (in %) in Euro area and Revenue generated (in %) in Nigeria?
Give a very brief answer. 15.36. In the year 2004, what is the difference between the Revenue generated (in %) of OECD members and Revenue generated (in %) of Nigeria?
Your answer should be compact. 18.39. In the year 2005, what is the difference between the Revenue generated (in %) of Caribbean small states and Revenue generated (in %) of Euro area?
Provide a short and direct response. 20.74. In the year 2005, what is the difference between the Revenue generated (in %) in Caribbean small states and Revenue generated (in %) in OECD members?
Offer a very short reply. 15.2. In the year 2005, what is the difference between the Revenue generated (in %) in Caribbean small states and Revenue generated (in %) in Nigeria?
Your answer should be compact. 20.1. In the year 2005, what is the difference between the Revenue generated (in %) in Euro area and Revenue generated (in %) in OECD members?
Your answer should be very brief. -5.54. In the year 2005, what is the difference between the Revenue generated (in %) in Euro area and Revenue generated (in %) in Nigeria?
Provide a short and direct response. -0.64. In the year 2005, what is the difference between the Revenue generated (in %) of OECD members and Revenue generated (in %) of Nigeria?
Make the answer very short. 4.9. In the year 2006, what is the difference between the Revenue generated (in %) in Caribbean small states and Revenue generated (in %) in Euro area?
Your response must be concise. 24.31. In the year 2006, what is the difference between the Revenue generated (in %) of Caribbean small states and Revenue generated (in %) of OECD members?
Give a very brief answer. 19.38. In the year 2006, what is the difference between the Revenue generated (in %) in Caribbean small states and Revenue generated (in %) in Nigeria?
Your answer should be compact. 25.36. In the year 2006, what is the difference between the Revenue generated (in %) of Euro area and Revenue generated (in %) of OECD members?
Provide a succinct answer. -4.93. In the year 2006, what is the difference between the Revenue generated (in %) in Euro area and Revenue generated (in %) in Nigeria?
Offer a terse response. 1.05. In the year 2006, what is the difference between the Revenue generated (in %) in OECD members and Revenue generated (in %) in Nigeria?
Ensure brevity in your answer.  5.99. In the year 2007, what is the difference between the Revenue generated (in %) in Caribbean small states and Revenue generated (in %) in Euro area?
Provide a succinct answer. 22.94. In the year 2007, what is the difference between the Revenue generated (in %) of Caribbean small states and Revenue generated (in %) of OECD members?
Your response must be concise. 17.02. In the year 2007, what is the difference between the Revenue generated (in %) of Caribbean small states and Revenue generated (in %) of Nigeria?
Offer a very short reply. 12.38. In the year 2007, what is the difference between the Revenue generated (in %) in Euro area and Revenue generated (in %) in OECD members?
Your answer should be very brief. -5.92. In the year 2007, what is the difference between the Revenue generated (in %) in Euro area and Revenue generated (in %) in Nigeria?
Your answer should be very brief. -10.56. In the year 2007, what is the difference between the Revenue generated (in %) in OECD members and Revenue generated (in %) in Nigeria?
Your answer should be compact. -4.64. In the year 2008, what is the difference between the Revenue generated (in %) of Caribbean small states and Revenue generated (in %) of Euro area?
Keep it short and to the point. 26.09. In the year 2008, what is the difference between the Revenue generated (in %) in Caribbean small states and Revenue generated (in %) in OECD members?
Offer a terse response. 23.4. In the year 2008, what is the difference between the Revenue generated (in %) of Caribbean small states and Revenue generated (in %) of Nigeria?
Ensure brevity in your answer.  9.31. In the year 2008, what is the difference between the Revenue generated (in %) in Euro area and Revenue generated (in %) in OECD members?
Keep it short and to the point. -2.68. In the year 2008, what is the difference between the Revenue generated (in %) of Euro area and Revenue generated (in %) of Nigeria?
Make the answer very short. -16.78. In the year 2008, what is the difference between the Revenue generated (in %) of OECD members and Revenue generated (in %) of Nigeria?
Your answer should be very brief. -14.1. In the year 2009, what is the difference between the Revenue generated (in %) of Caribbean small states and Revenue generated (in %) of Euro area?
Make the answer very short. 20.82. In the year 2009, what is the difference between the Revenue generated (in %) of Caribbean small states and Revenue generated (in %) of OECD members?
Give a very brief answer. 18.19. In the year 2009, what is the difference between the Revenue generated (in %) in Caribbean small states and Revenue generated (in %) in Nigeria?
Provide a short and direct response. -3.91. In the year 2009, what is the difference between the Revenue generated (in %) of Euro area and Revenue generated (in %) of OECD members?
Give a very brief answer. -2.63. In the year 2009, what is the difference between the Revenue generated (in %) in Euro area and Revenue generated (in %) in Nigeria?
Your answer should be compact. -24.73. In the year 2009, what is the difference between the Revenue generated (in %) of OECD members and Revenue generated (in %) of Nigeria?
Your response must be concise. -22.1. In the year 2010, what is the difference between the Revenue generated (in %) in Caribbean small states and Revenue generated (in %) in Euro area?
Keep it short and to the point. 19.7. In the year 2010, what is the difference between the Revenue generated (in %) of Caribbean small states and Revenue generated (in %) of OECD members?
Your answer should be compact. 17.78. In the year 2010, what is the difference between the Revenue generated (in %) in Caribbean small states and Revenue generated (in %) in Nigeria?
Your answer should be very brief. 2.41. In the year 2010, what is the difference between the Revenue generated (in %) of Euro area and Revenue generated (in %) of OECD members?
Keep it short and to the point. -1.91. In the year 2010, what is the difference between the Revenue generated (in %) in Euro area and Revenue generated (in %) in Nigeria?
Your answer should be very brief. -17.29. In the year 2010, what is the difference between the Revenue generated (in %) in OECD members and Revenue generated (in %) in Nigeria?
Make the answer very short. -15.38. In the year 2011, what is the difference between the Revenue generated (in %) of Caribbean small states and Revenue generated (in %) of Euro area?
Provide a short and direct response. 10.25. In the year 2011, what is the difference between the Revenue generated (in %) in Caribbean small states and Revenue generated (in %) in OECD members?
Your response must be concise. 8.38. In the year 2011, what is the difference between the Revenue generated (in %) of Caribbean small states and Revenue generated (in %) of Nigeria?
Offer a very short reply. 2.12. In the year 2011, what is the difference between the Revenue generated (in %) in Euro area and Revenue generated (in %) in OECD members?
Keep it short and to the point. -1.87. In the year 2011, what is the difference between the Revenue generated (in %) of Euro area and Revenue generated (in %) of Nigeria?
Give a very brief answer. -8.13. In the year 2011, what is the difference between the Revenue generated (in %) of OECD members and Revenue generated (in %) of Nigeria?
Make the answer very short. -6.26. What is the ratio of the Revenue generated (in %) in Caribbean small states in 2004 to that in 2005?
Your answer should be compact. 0.9. What is the ratio of the Revenue generated (in %) in Euro area in 2004 to that in 2005?
Your answer should be compact. 0.98. What is the ratio of the Revenue generated (in %) of OECD members in 2004 to that in 2005?
Offer a terse response. 0.89. What is the ratio of the Revenue generated (in %) of Nigeria in 2004 to that in 2005?
Keep it short and to the point. 0.27. What is the ratio of the Revenue generated (in %) in Caribbean small states in 2004 to that in 2006?
Provide a succinct answer. 0.81. What is the ratio of the Revenue generated (in %) of Euro area in 2004 to that in 2006?
Ensure brevity in your answer.  0.95. What is the ratio of the Revenue generated (in %) of OECD members in 2004 to that in 2006?
Give a very brief answer. 0.89. What is the ratio of the Revenue generated (in %) in Nigeria in 2004 to that in 2006?
Make the answer very short. 0.29. What is the ratio of the Revenue generated (in %) in Caribbean small states in 2004 to that in 2007?
Provide a short and direct response. 0.83. What is the ratio of the Revenue generated (in %) of Euro area in 2004 to that in 2007?
Your answer should be very brief. 0.92. What is the ratio of the Revenue generated (in %) in OECD members in 2004 to that in 2007?
Offer a terse response. 0.84. What is the ratio of the Revenue generated (in %) in Nigeria in 2004 to that in 2007?
Provide a succinct answer. 0.18. What is the ratio of the Revenue generated (in %) in Caribbean small states in 2004 to that in 2008?
Your answer should be very brief. 0.77. What is the ratio of the Revenue generated (in %) of Euro area in 2004 to that in 2008?
Ensure brevity in your answer.  0.91. What is the ratio of the Revenue generated (in %) of OECD members in 2004 to that in 2008?
Your answer should be compact. 0.94. What is the ratio of the Revenue generated (in %) in Nigeria in 2004 to that in 2008?
Give a very brief answer. 0.15. What is the ratio of the Revenue generated (in %) in Caribbean small states in 2004 to that in 2009?
Make the answer very short. 0.9. What is the ratio of the Revenue generated (in %) in Euro area in 2004 to that in 2009?
Ensure brevity in your answer.  1. What is the ratio of the Revenue generated (in %) of OECD members in 2004 to that in 2009?
Give a very brief answer. 1.02. What is the ratio of the Revenue generated (in %) in Nigeria in 2004 to that in 2009?
Make the answer very short. 0.13. What is the ratio of the Revenue generated (in %) in Caribbean small states in 2004 to that in 2010?
Your answer should be very brief. 0.94. What is the ratio of the Revenue generated (in %) of Euro area in 2004 to that in 2010?
Offer a terse response. 1.03. What is the ratio of the Revenue generated (in %) in OECD members in 2004 to that in 2010?
Ensure brevity in your answer.  1.08. What is the ratio of the Revenue generated (in %) of Nigeria in 2004 to that in 2010?
Your answer should be compact. 0.16. What is the ratio of the Revenue generated (in %) of Caribbean small states in 2004 to that in 2011?
Provide a short and direct response. 1.2. What is the ratio of the Revenue generated (in %) in Euro area in 2004 to that in 2011?
Provide a short and direct response. 1. What is the ratio of the Revenue generated (in %) of OECD members in 2004 to that in 2011?
Make the answer very short. 1.05. What is the ratio of the Revenue generated (in %) of Nigeria in 2004 to that in 2011?
Your response must be concise. 0.21. What is the ratio of the Revenue generated (in %) of Caribbean small states in 2005 to that in 2006?
Make the answer very short. 0.91. What is the ratio of the Revenue generated (in %) in Euro area in 2005 to that in 2006?
Keep it short and to the point. 0.97. What is the ratio of the Revenue generated (in %) in Nigeria in 2005 to that in 2006?
Provide a succinct answer. 1.05. What is the ratio of the Revenue generated (in %) in Caribbean small states in 2005 to that in 2007?
Keep it short and to the point. 0.92. What is the ratio of the Revenue generated (in %) in Euro area in 2005 to that in 2007?
Give a very brief answer. 0.94. What is the ratio of the Revenue generated (in %) of Nigeria in 2005 to that in 2007?
Ensure brevity in your answer.  0.67. What is the ratio of the Revenue generated (in %) in Caribbean small states in 2005 to that in 2008?
Provide a succinct answer. 0.86. What is the ratio of the Revenue generated (in %) of Euro area in 2005 to that in 2008?
Provide a succinct answer. 0.93. What is the ratio of the Revenue generated (in %) of OECD members in 2005 to that in 2008?
Your response must be concise. 1.05. What is the ratio of the Revenue generated (in %) of Nigeria in 2005 to that in 2008?
Keep it short and to the point. 0.56. What is the ratio of the Revenue generated (in %) of Caribbean small states in 2005 to that in 2009?
Your answer should be compact. 1.01. What is the ratio of the Revenue generated (in %) of Euro area in 2005 to that in 2009?
Your answer should be very brief. 1.02. What is the ratio of the Revenue generated (in %) of OECD members in 2005 to that in 2009?
Your response must be concise. 1.14. What is the ratio of the Revenue generated (in %) of Nigeria in 2005 to that in 2009?
Give a very brief answer. 0.49. What is the ratio of the Revenue generated (in %) of Caribbean small states in 2005 to that in 2010?
Keep it short and to the point. 1.05. What is the ratio of the Revenue generated (in %) of Euro area in 2005 to that in 2010?
Your response must be concise. 1.05. What is the ratio of the Revenue generated (in %) in OECD members in 2005 to that in 2010?
Provide a short and direct response. 1.21. What is the ratio of the Revenue generated (in %) in Nigeria in 2005 to that in 2010?
Offer a very short reply. 0.59. What is the ratio of the Revenue generated (in %) in Caribbean small states in 2005 to that in 2011?
Give a very brief answer. 1.34. What is the ratio of the Revenue generated (in %) in Euro area in 2005 to that in 2011?
Ensure brevity in your answer.  1.02. What is the ratio of the Revenue generated (in %) in OECD members in 2005 to that in 2011?
Ensure brevity in your answer.  1.17. What is the ratio of the Revenue generated (in %) of Nigeria in 2005 to that in 2011?
Give a very brief answer. 0.76. What is the ratio of the Revenue generated (in %) in Caribbean small states in 2006 to that in 2007?
Make the answer very short. 1.02. What is the ratio of the Revenue generated (in %) in Euro area in 2006 to that in 2007?
Provide a short and direct response. 0.97. What is the ratio of the Revenue generated (in %) in OECD members in 2006 to that in 2007?
Keep it short and to the point. 0.94. What is the ratio of the Revenue generated (in %) in Nigeria in 2006 to that in 2007?
Your answer should be very brief. 0.64. What is the ratio of the Revenue generated (in %) in Caribbean small states in 2006 to that in 2008?
Your response must be concise. 0.94. What is the ratio of the Revenue generated (in %) of Euro area in 2006 to that in 2008?
Your response must be concise. 0.96. What is the ratio of the Revenue generated (in %) in OECD members in 2006 to that in 2008?
Offer a very short reply. 1.05. What is the ratio of the Revenue generated (in %) of Nigeria in 2006 to that in 2008?
Your answer should be very brief. 0.53. What is the ratio of the Revenue generated (in %) in Caribbean small states in 2006 to that in 2009?
Provide a short and direct response. 1.11. What is the ratio of the Revenue generated (in %) in Euro area in 2006 to that in 2009?
Your response must be concise. 1.05. What is the ratio of the Revenue generated (in %) of OECD members in 2006 to that in 2009?
Your answer should be compact. 1.14. What is the ratio of the Revenue generated (in %) in Nigeria in 2006 to that in 2009?
Offer a very short reply. 0.47. What is the ratio of the Revenue generated (in %) in Caribbean small states in 2006 to that in 2010?
Your answer should be very brief. 1.16. What is the ratio of the Revenue generated (in %) in Euro area in 2006 to that in 2010?
Ensure brevity in your answer.  1.09. What is the ratio of the Revenue generated (in %) in OECD members in 2006 to that in 2010?
Offer a terse response. 1.21. What is the ratio of the Revenue generated (in %) in Nigeria in 2006 to that in 2010?
Offer a very short reply. 0.57. What is the ratio of the Revenue generated (in %) of Caribbean small states in 2006 to that in 2011?
Offer a terse response. 1.47. What is the ratio of the Revenue generated (in %) in Euro area in 2006 to that in 2011?
Your answer should be very brief. 1.05. What is the ratio of the Revenue generated (in %) in OECD members in 2006 to that in 2011?
Your answer should be very brief. 1.17. What is the ratio of the Revenue generated (in %) of Nigeria in 2006 to that in 2011?
Give a very brief answer. 0.72. What is the ratio of the Revenue generated (in %) of Caribbean small states in 2007 to that in 2008?
Provide a succinct answer. 0.93. What is the ratio of the Revenue generated (in %) of Euro area in 2007 to that in 2008?
Make the answer very short. 0.99. What is the ratio of the Revenue generated (in %) in OECD members in 2007 to that in 2008?
Your response must be concise. 1.11. What is the ratio of the Revenue generated (in %) of Nigeria in 2007 to that in 2008?
Ensure brevity in your answer.  0.84. What is the ratio of the Revenue generated (in %) in Caribbean small states in 2007 to that in 2009?
Ensure brevity in your answer.  1.09. What is the ratio of the Revenue generated (in %) in Euro area in 2007 to that in 2009?
Your answer should be compact. 1.08. What is the ratio of the Revenue generated (in %) in OECD members in 2007 to that in 2009?
Provide a short and direct response. 1.21. What is the ratio of the Revenue generated (in %) in Nigeria in 2007 to that in 2009?
Make the answer very short. 0.73. What is the ratio of the Revenue generated (in %) of Caribbean small states in 2007 to that in 2010?
Your response must be concise. 1.14. What is the ratio of the Revenue generated (in %) in Euro area in 2007 to that in 2010?
Give a very brief answer. 1.12. What is the ratio of the Revenue generated (in %) in OECD members in 2007 to that in 2010?
Make the answer very short. 1.28. What is the ratio of the Revenue generated (in %) of Nigeria in 2007 to that in 2010?
Offer a terse response. 0.89. What is the ratio of the Revenue generated (in %) in Caribbean small states in 2007 to that in 2011?
Offer a terse response. 1.45. What is the ratio of the Revenue generated (in %) of Euro area in 2007 to that in 2011?
Your answer should be very brief. 1.08. What is the ratio of the Revenue generated (in %) of OECD members in 2007 to that in 2011?
Provide a succinct answer. 1.24. What is the ratio of the Revenue generated (in %) in Nigeria in 2007 to that in 2011?
Provide a short and direct response. 1.14. What is the ratio of the Revenue generated (in %) of Caribbean small states in 2008 to that in 2009?
Make the answer very short. 1.17. What is the ratio of the Revenue generated (in %) of Euro area in 2008 to that in 2009?
Offer a very short reply. 1.1. What is the ratio of the Revenue generated (in %) in OECD members in 2008 to that in 2009?
Make the answer very short. 1.09. What is the ratio of the Revenue generated (in %) of Nigeria in 2008 to that in 2009?
Your answer should be compact. 0.87. What is the ratio of the Revenue generated (in %) of Caribbean small states in 2008 to that in 2010?
Offer a terse response. 1.23. What is the ratio of the Revenue generated (in %) of Euro area in 2008 to that in 2010?
Make the answer very short. 1.13. What is the ratio of the Revenue generated (in %) in OECD members in 2008 to that in 2010?
Your answer should be very brief. 1.15. What is the ratio of the Revenue generated (in %) in Nigeria in 2008 to that in 2010?
Offer a terse response. 1.06. What is the ratio of the Revenue generated (in %) in Caribbean small states in 2008 to that in 2011?
Make the answer very short. 1.56. What is the ratio of the Revenue generated (in %) in Euro area in 2008 to that in 2011?
Offer a terse response. 1.09. What is the ratio of the Revenue generated (in %) of OECD members in 2008 to that in 2011?
Make the answer very short. 1.12. What is the ratio of the Revenue generated (in %) of Nigeria in 2008 to that in 2011?
Ensure brevity in your answer.  1.36. What is the ratio of the Revenue generated (in %) of Caribbean small states in 2009 to that in 2010?
Provide a succinct answer. 1.04. What is the ratio of the Revenue generated (in %) of Euro area in 2009 to that in 2010?
Provide a short and direct response. 1.03. What is the ratio of the Revenue generated (in %) in OECD members in 2009 to that in 2010?
Offer a terse response. 1.06. What is the ratio of the Revenue generated (in %) in Nigeria in 2009 to that in 2010?
Your answer should be compact. 1.21. What is the ratio of the Revenue generated (in %) of Caribbean small states in 2009 to that in 2011?
Keep it short and to the point. 1.33. What is the ratio of the Revenue generated (in %) of Euro area in 2009 to that in 2011?
Keep it short and to the point. 1. What is the ratio of the Revenue generated (in %) of OECD members in 2009 to that in 2011?
Your answer should be very brief. 1.03. What is the ratio of the Revenue generated (in %) of Nigeria in 2009 to that in 2011?
Your answer should be compact. 1.56. What is the ratio of the Revenue generated (in %) of Caribbean small states in 2010 to that in 2011?
Your answer should be compact. 1.27. What is the ratio of the Revenue generated (in %) in OECD members in 2010 to that in 2011?
Your answer should be very brief. 0.97. What is the ratio of the Revenue generated (in %) of Nigeria in 2010 to that in 2011?
Your answer should be compact. 1.28. What is the difference between the highest and the second highest Revenue generated (in %) of Caribbean small states?
Your answer should be very brief. 2.74. What is the difference between the highest and the second highest Revenue generated (in %) of Euro area?
Offer a very short reply. 0.29. What is the difference between the highest and the second highest Revenue generated (in %) of OECD members?
Provide a succinct answer. 1.65. What is the difference between the highest and the second highest Revenue generated (in %) in Nigeria?
Your answer should be very brief. 5.9. What is the difference between the highest and the lowest Revenue generated (in %) in Caribbean small states?
Offer a very short reply. 17.81. What is the difference between the highest and the lowest Revenue generated (in %) of Euro area?
Offer a very short reply. 2.74. What is the difference between the highest and the lowest Revenue generated (in %) of OECD members?
Provide a short and direct response. 6.46. What is the difference between the highest and the lowest Revenue generated (in %) of Nigeria?
Ensure brevity in your answer.  40.08. 